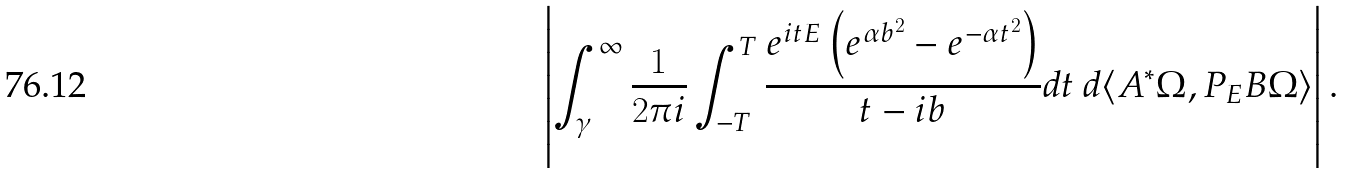Convert formula to latex. <formula><loc_0><loc_0><loc_500><loc_500>\left | \int _ { \gamma } ^ { \infty } \frac { 1 } { 2 \pi i } \int _ { - T } ^ { T } \frac { e ^ { i t E } \left ( e ^ { \alpha b ^ { 2 } } - e ^ { - \alpha t ^ { 2 } } \right ) } { t - i b } d t \, d \langle A ^ { * } \Omega , P _ { E } B \Omega \rangle \right | .</formula> 